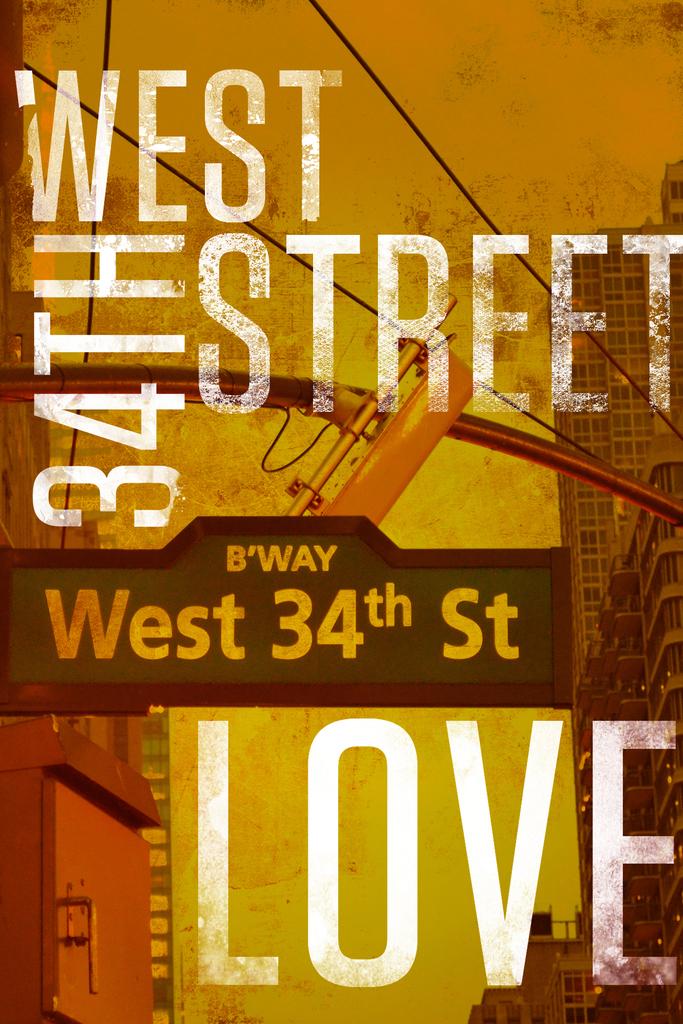What is the address on the flyer?
Make the answer very short. West 34th street. 